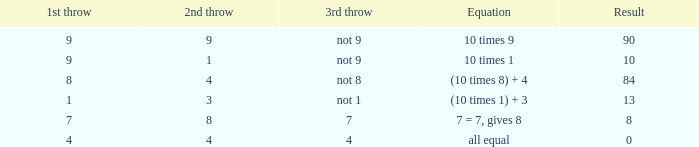What happens when the third throw does not produce an 8? 84.0. 